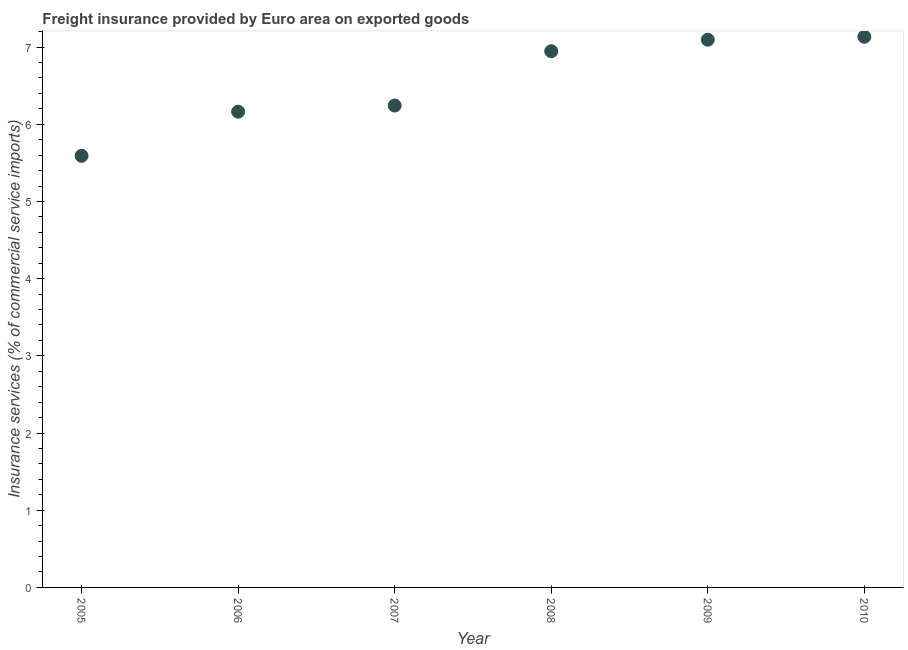What is the freight insurance in 2008?
Provide a succinct answer. 6.95. Across all years, what is the maximum freight insurance?
Provide a succinct answer. 7.13. Across all years, what is the minimum freight insurance?
Make the answer very short. 5.59. What is the sum of the freight insurance?
Offer a very short reply. 39.17. What is the difference between the freight insurance in 2006 and 2009?
Your answer should be very brief. -0.93. What is the average freight insurance per year?
Your response must be concise. 6.53. What is the median freight insurance?
Your response must be concise. 6.59. In how many years, is the freight insurance greater than 4.2 %?
Offer a terse response. 6. Do a majority of the years between 2007 and 2010 (inclusive) have freight insurance greater than 0.6000000000000001 %?
Provide a succinct answer. Yes. What is the ratio of the freight insurance in 2005 to that in 2010?
Your answer should be very brief. 0.78. Is the freight insurance in 2009 less than that in 2010?
Make the answer very short. Yes. Is the difference between the freight insurance in 2005 and 2007 greater than the difference between any two years?
Give a very brief answer. No. What is the difference between the highest and the second highest freight insurance?
Keep it short and to the point. 0.04. What is the difference between the highest and the lowest freight insurance?
Provide a succinct answer. 1.54. How many dotlines are there?
Ensure brevity in your answer.  1. What is the difference between two consecutive major ticks on the Y-axis?
Make the answer very short. 1. Are the values on the major ticks of Y-axis written in scientific E-notation?
Ensure brevity in your answer.  No. What is the title of the graph?
Your answer should be very brief. Freight insurance provided by Euro area on exported goods . What is the label or title of the Y-axis?
Your answer should be compact. Insurance services (% of commercial service imports). What is the Insurance services (% of commercial service imports) in 2005?
Your answer should be very brief. 5.59. What is the Insurance services (% of commercial service imports) in 2006?
Make the answer very short. 6.16. What is the Insurance services (% of commercial service imports) in 2007?
Your answer should be compact. 6.24. What is the Insurance services (% of commercial service imports) in 2008?
Provide a short and direct response. 6.95. What is the Insurance services (% of commercial service imports) in 2009?
Offer a terse response. 7.1. What is the Insurance services (% of commercial service imports) in 2010?
Offer a terse response. 7.13. What is the difference between the Insurance services (% of commercial service imports) in 2005 and 2006?
Offer a terse response. -0.57. What is the difference between the Insurance services (% of commercial service imports) in 2005 and 2007?
Make the answer very short. -0.65. What is the difference between the Insurance services (% of commercial service imports) in 2005 and 2008?
Keep it short and to the point. -1.36. What is the difference between the Insurance services (% of commercial service imports) in 2005 and 2009?
Offer a very short reply. -1.5. What is the difference between the Insurance services (% of commercial service imports) in 2005 and 2010?
Offer a very short reply. -1.54. What is the difference between the Insurance services (% of commercial service imports) in 2006 and 2007?
Your answer should be compact. -0.08. What is the difference between the Insurance services (% of commercial service imports) in 2006 and 2008?
Your answer should be compact. -0.78. What is the difference between the Insurance services (% of commercial service imports) in 2006 and 2009?
Provide a succinct answer. -0.93. What is the difference between the Insurance services (% of commercial service imports) in 2006 and 2010?
Your answer should be compact. -0.97. What is the difference between the Insurance services (% of commercial service imports) in 2007 and 2008?
Offer a terse response. -0.7. What is the difference between the Insurance services (% of commercial service imports) in 2007 and 2009?
Your response must be concise. -0.85. What is the difference between the Insurance services (% of commercial service imports) in 2007 and 2010?
Offer a terse response. -0.89. What is the difference between the Insurance services (% of commercial service imports) in 2008 and 2009?
Give a very brief answer. -0.15. What is the difference between the Insurance services (% of commercial service imports) in 2008 and 2010?
Your answer should be very brief. -0.19. What is the difference between the Insurance services (% of commercial service imports) in 2009 and 2010?
Give a very brief answer. -0.04. What is the ratio of the Insurance services (% of commercial service imports) in 2005 to that in 2006?
Offer a very short reply. 0.91. What is the ratio of the Insurance services (% of commercial service imports) in 2005 to that in 2007?
Provide a succinct answer. 0.9. What is the ratio of the Insurance services (% of commercial service imports) in 2005 to that in 2008?
Provide a succinct answer. 0.81. What is the ratio of the Insurance services (% of commercial service imports) in 2005 to that in 2009?
Your response must be concise. 0.79. What is the ratio of the Insurance services (% of commercial service imports) in 2005 to that in 2010?
Offer a very short reply. 0.78. What is the ratio of the Insurance services (% of commercial service imports) in 2006 to that in 2008?
Give a very brief answer. 0.89. What is the ratio of the Insurance services (% of commercial service imports) in 2006 to that in 2009?
Your response must be concise. 0.87. What is the ratio of the Insurance services (% of commercial service imports) in 2006 to that in 2010?
Offer a terse response. 0.86. What is the ratio of the Insurance services (% of commercial service imports) in 2007 to that in 2008?
Your response must be concise. 0.9. What is the ratio of the Insurance services (% of commercial service imports) in 2007 to that in 2009?
Your response must be concise. 0.88. What is the ratio of the Insurance services (% of commercial service imports) in 2007 to that in 2010?
Make the answer very short. 0.88. What is the ratio of the Insurance services (% of commercial service imports) in 2008 to that in 2009?
Keep it short and to the point. 0.98. What is the ratio of the Insurance services (% of commercial service imports) in 2009 to that in 2010?
Give a very brief answer. 0.99. 